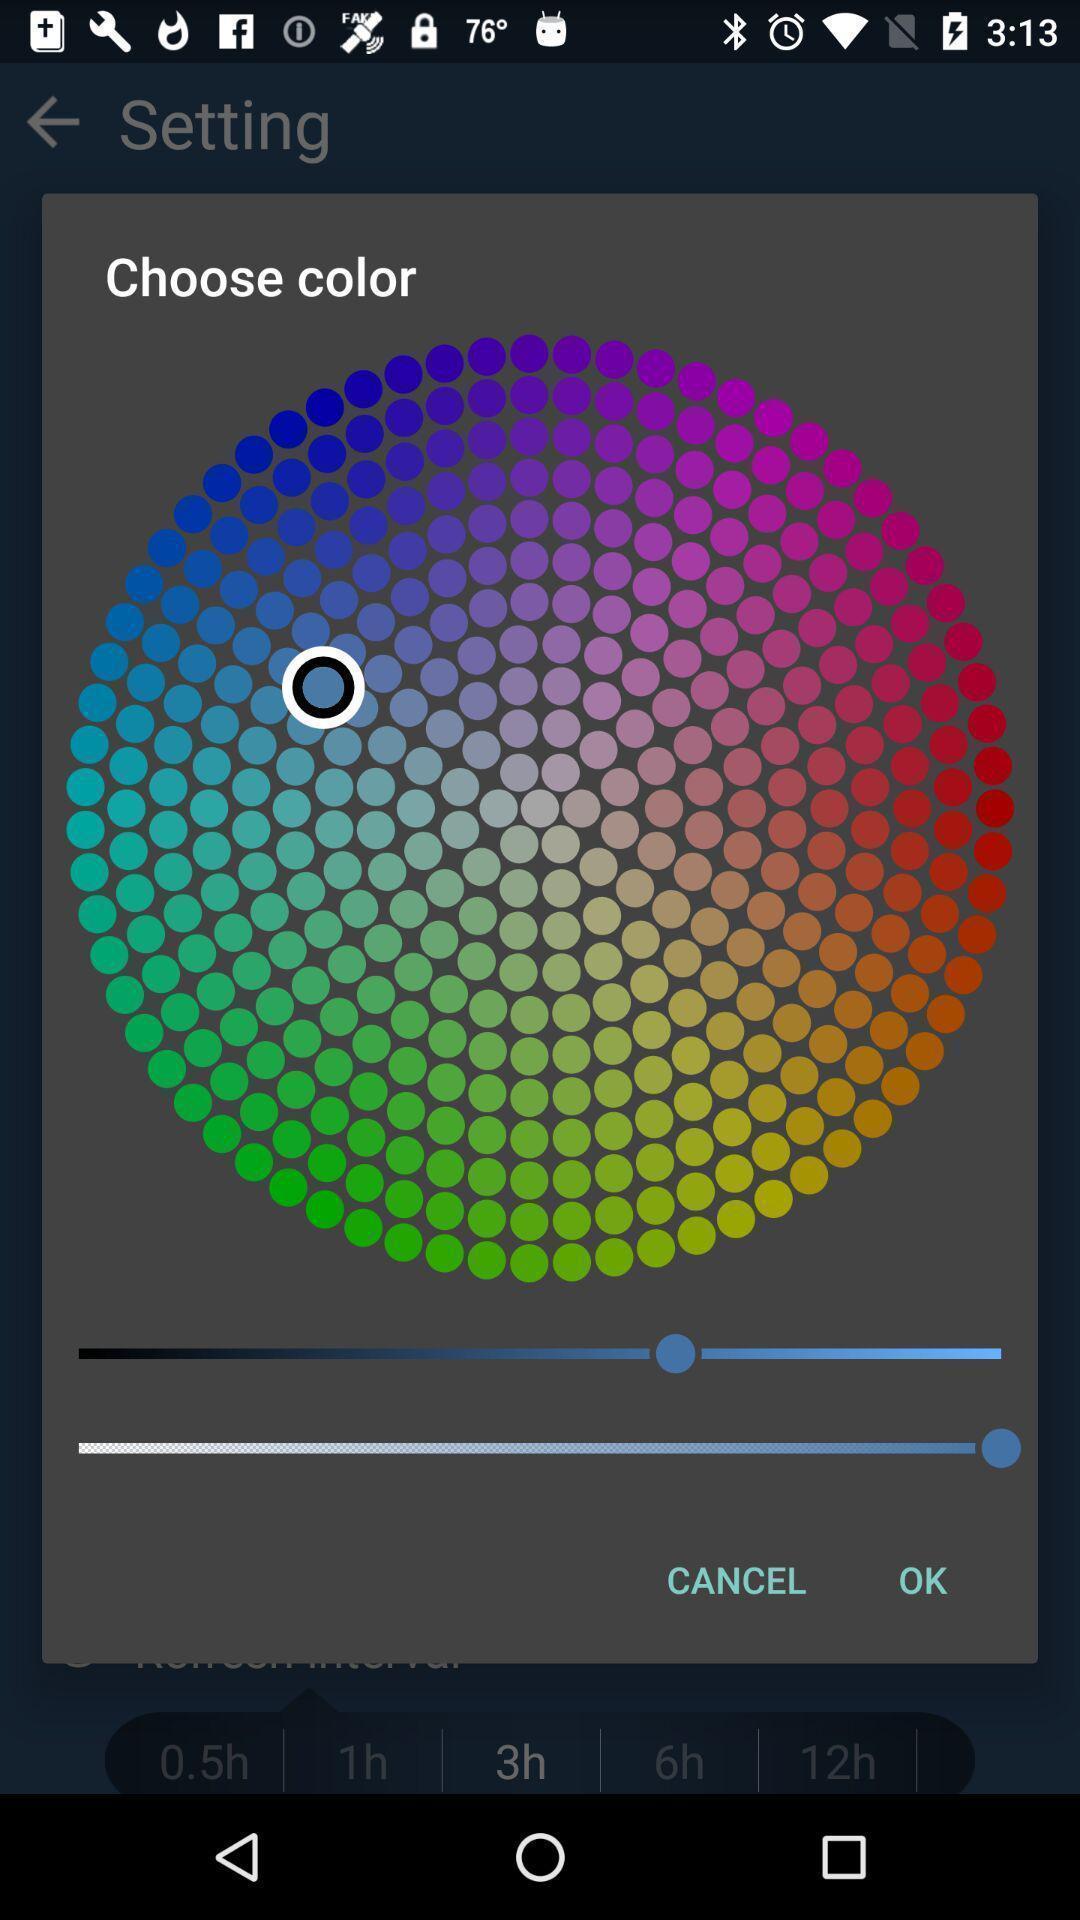Describe the content in this image. Pop-up showing different colors to choose. 